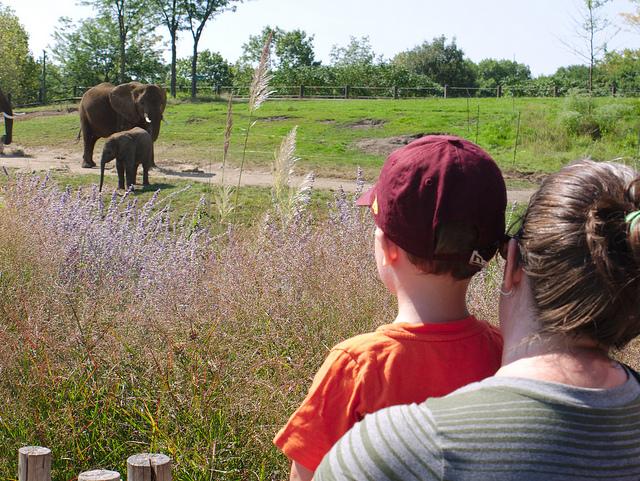How many elephants are in the field?
Write a very short answer. 2. Are the woman and child a reasonably safe distance from the animals?
Be succinct. Yes. What color is the boys shirt?
Be succinct. Orange. How many people in ponchos?
Concise answer only. 0. What is on the boys head?
Keep it brief. Hat. 